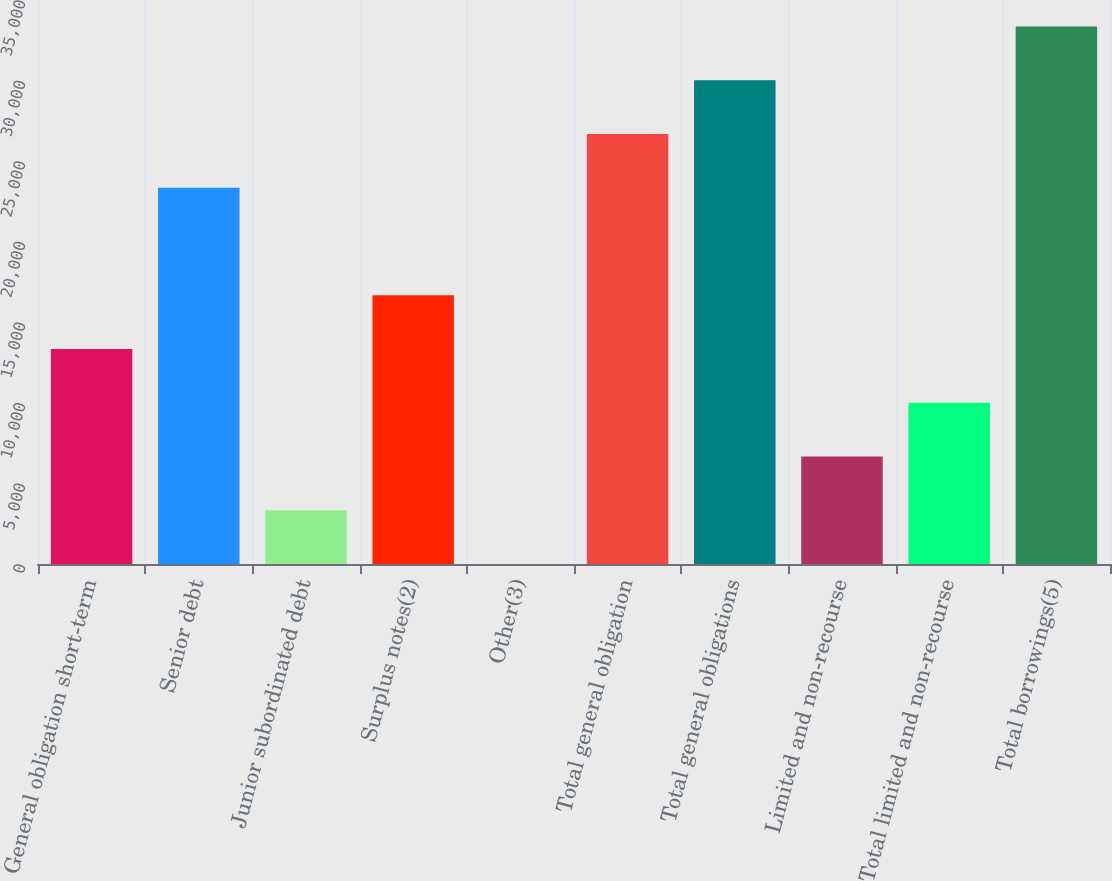<chart> <loc_0><loc_0><loc_500><loc_500><bar_chart><fcel>General obligation short-term<fcel>Senior debt<fcel>Junior subordinated debt<fcel>Surplus notes(2)<fcel>Other(3)<fcel>Total general obligation<fcel>Total general obligations<fcel>Limited and non-recourse<fcel>Total limited and non-recourse<fcel>Total borrowings(5)<nl><fcel>13343.7<fcel>23349.9<fcel>3337.6<fcel>16679.1<fcel>2.22<fcel>26685.3<fcel>30020.6<fcel>6672.98<fcel>10008.4<fcel>33356<nl></chart> 